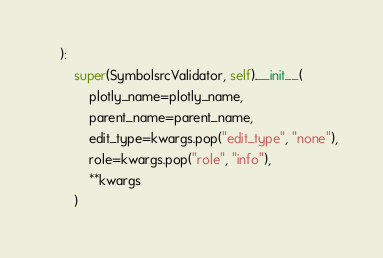Convert code to text. <code><loc_0><loc_0><loc_500><loc_500><_Python_>    ):
        super(SymbolsrcValidator, self).__init__(
            plotly_name=plotly_name,
            parent_name=parent_name,
            edit_type=kwargs.pop("edit_type", "none"),
            role=kwargs.pop("role", "info"),
            **kwargs
        )
</code> 